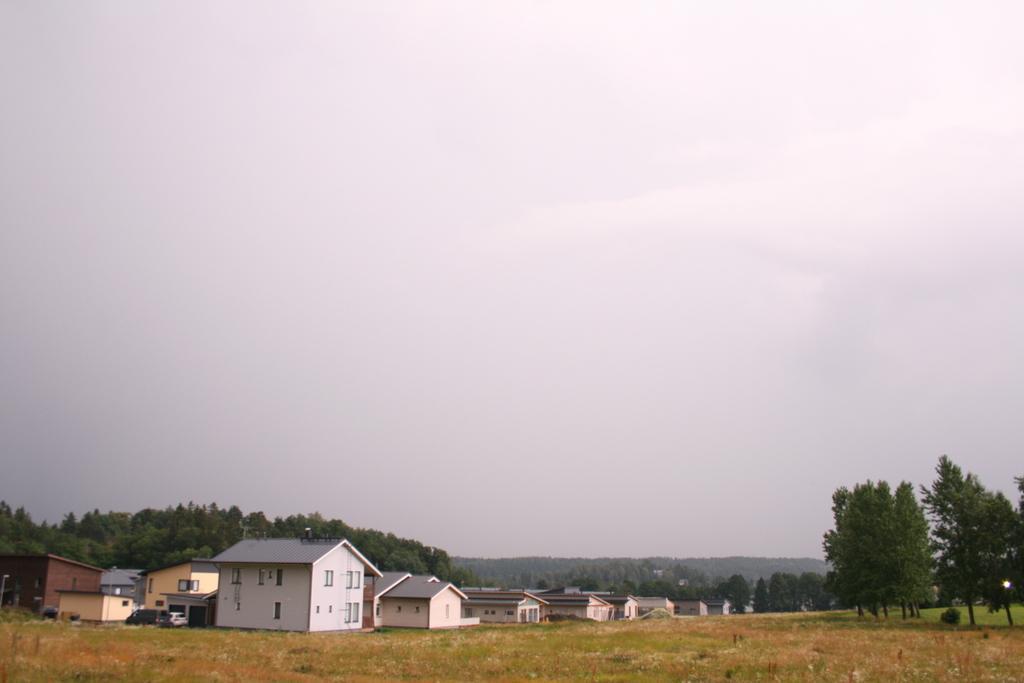Please provide a concise description of this image. In this image, at the bottom there are houses, vehicles, trees, grass, and, sky and clouds. 